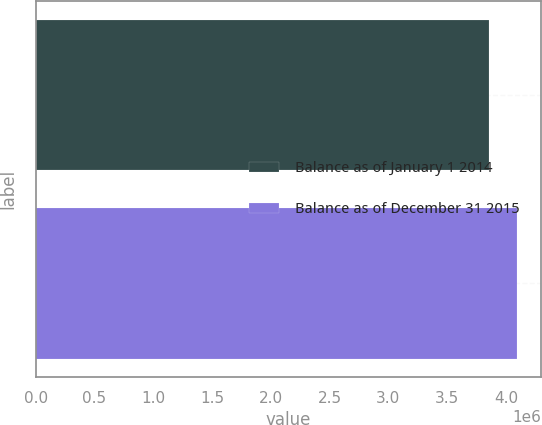<chart> <loc_0><loc_0><loc_500><loc_500><bar_chart><fcel>Balance as of January 1 2014<fcel>Balance as of December 31 2015<nl><fcel>3.8548e+06<fcel>4.0918e+06<nl></chart> 